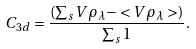Convert formula to latex. <formula><loc_0><loc_0><loc_500><loc_500>C _ { 3 d } = \frac { ( \sum _ { s } V \rho _ { \lambda } - < V \rho _ { \lambda } > ) } { \sum _ { s } 1 } .</formula> 